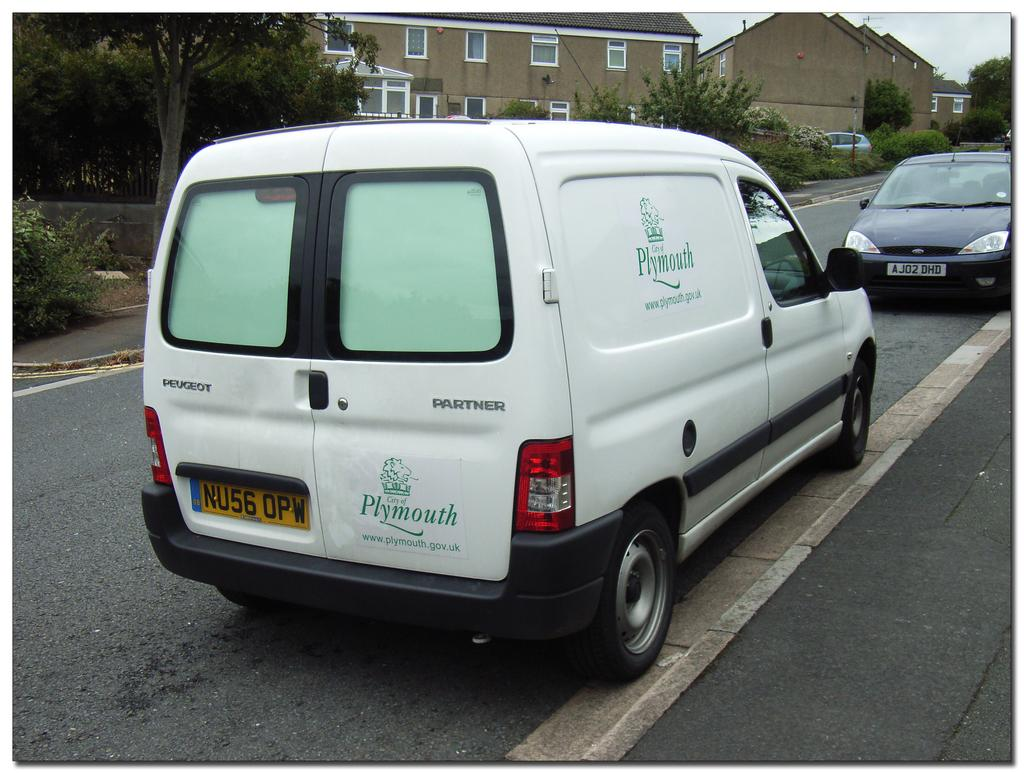Provide a one-sentence caption for the provided image. A white Plymouth government van parked on a suburban street. 